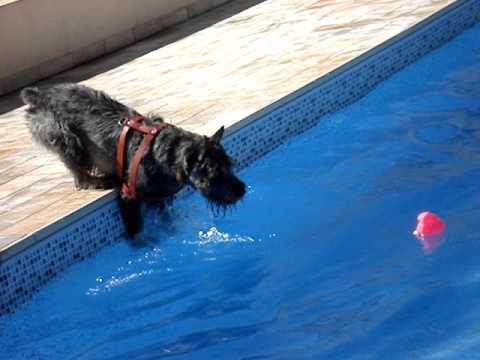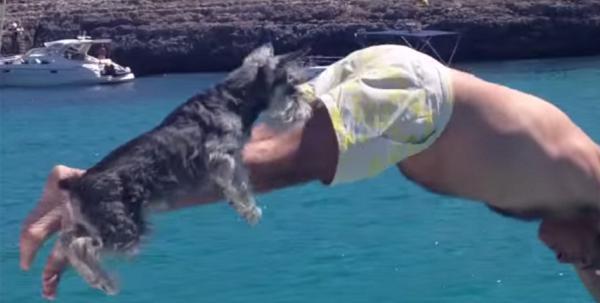The first image is the image on the left, the second image is the image on the right. Evaluate the accuracy of this statement regarding the images: "Exactly one dog is partly in the water.". Is it true? Answer yes or no. Yes. The first image is the image on the left, the second image is the image on the right. Examine the images to the left and right. Is the description "two dogs are on the side of the pool looking at the water" accurate? Answer yes or no. No. 